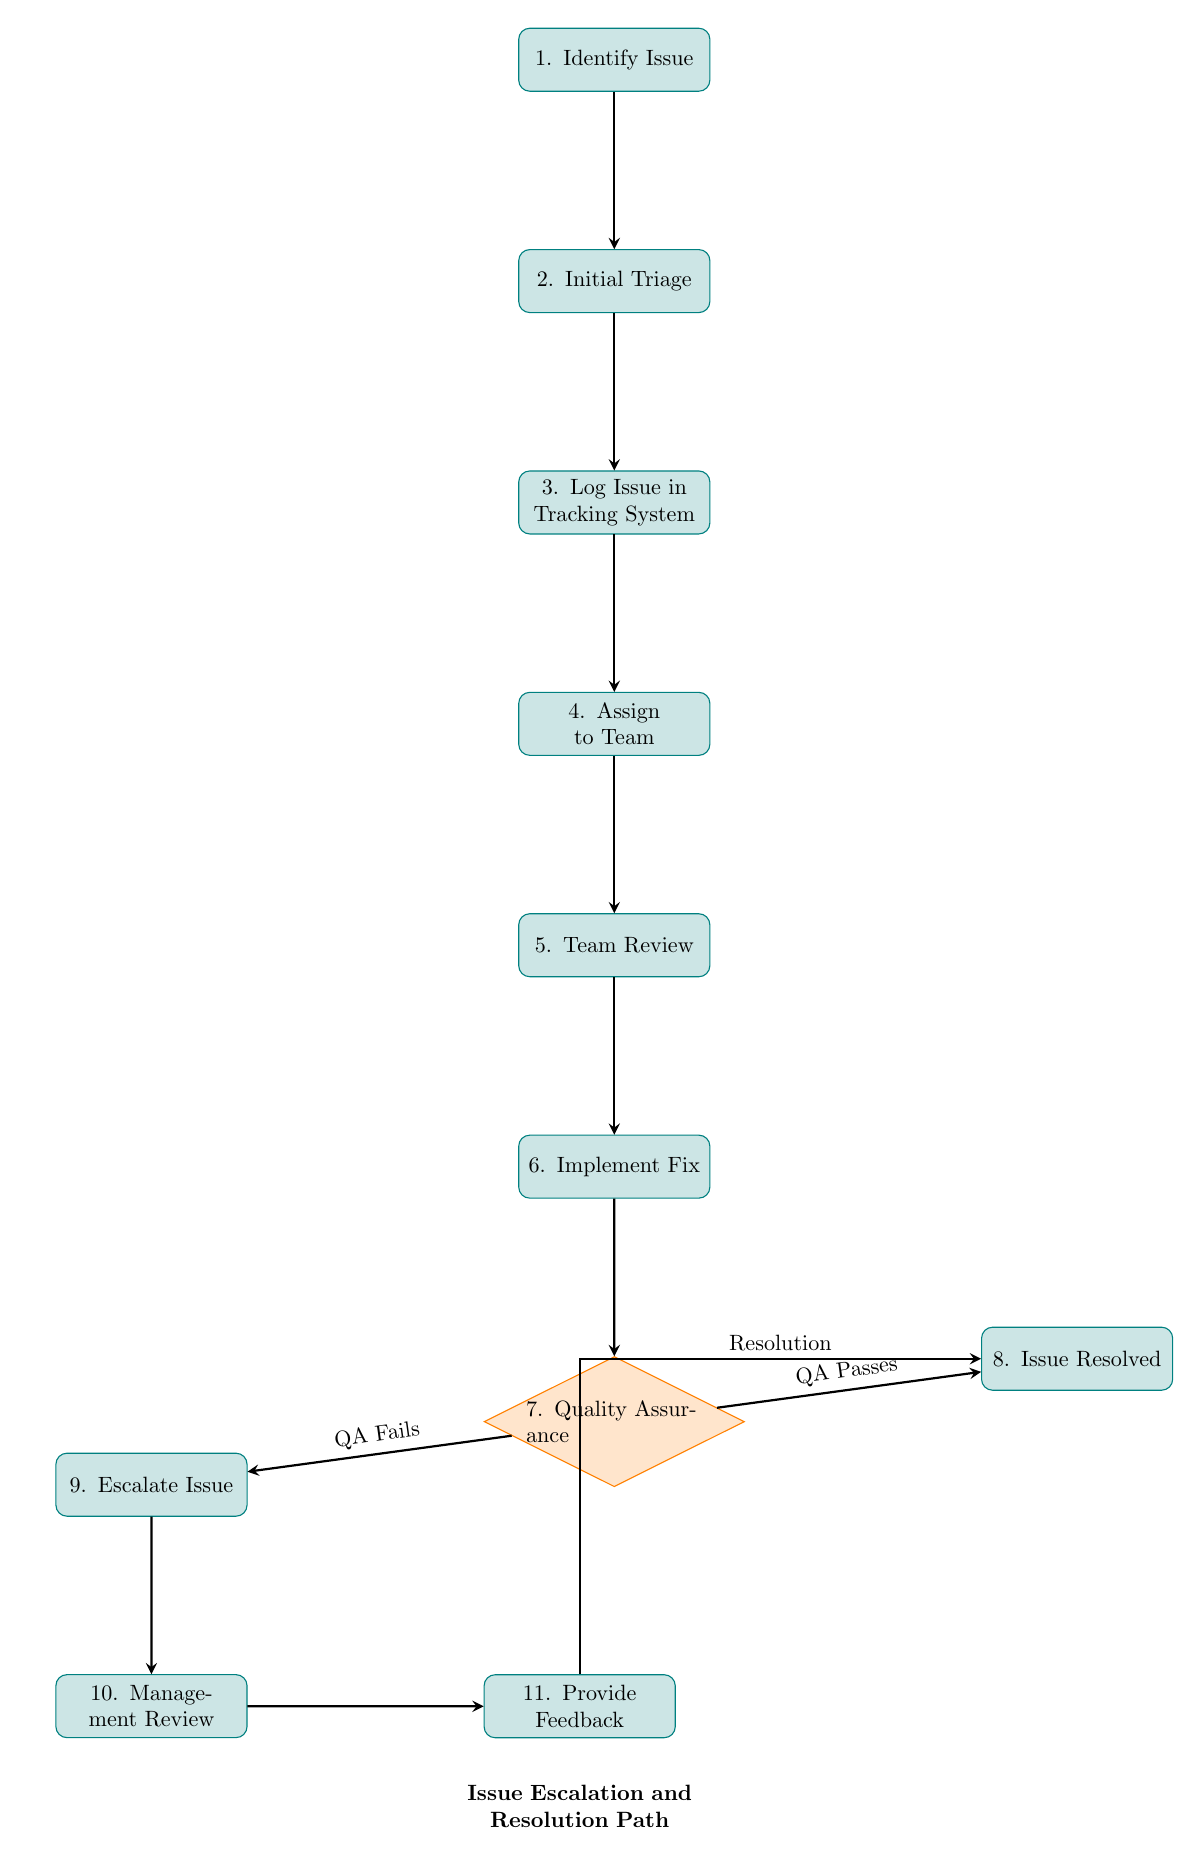What is the first step in the issue escalation process? The first step is represented by the first node labeled "Identify Issue." This is where the process starts, as the identification and documentation of the bug or issue is crucial.
Answer: Identify Issue How many nodes are present in the diagram? To determine the total number of nodes, count each unique step represented in the diagram, which are the processes and decisions involved in the escalation. There are a total of 11 nodes.
Answer: 11 What is the condition for moving to the "Escalate Issue" node? The "Escalate Issue" node is reached if the Quality Assurance process indicates that the issue "QA Fails." This condition dictates the alternative path taken when the quality check does not pass.
Answer: QA Fails What is the final step after "Management Review"? After "Management Review," the next step is "Provide Feedback," where the outcome of the escalation is communicated and documented. This is a crucial final action following the review process.
Answer: Provide Feedback What occurs if the QA team passes the fix? If the QA team passes the fix, the next step is to mark the issue as "Issue Resolved," documenting that the problem has been successfully addressed without introducing new issues.
Answer: Issue Resolved Which node comes after "Team Review"? The node that follows "Team Review" is "Implement Fix." This indicates that after reviewing the issue, the team proceeds to actively work on fixing it.
Answer: Implement Fix What happens if the issue is escalated? If the issue is escalated, it is forwarded to "Management Review." This represents a shift in responsibility where higher management or specialized teams take over the issue for further analysis.
Answer: Management Review What is the output of the process after "Provide Feedback"? After "Provide Feedback," the process can circle back to "Issue Resolved," indicating that stakeholders are informed and the resolution has been documented in the tracking system.
Answer: Issue Resolved 